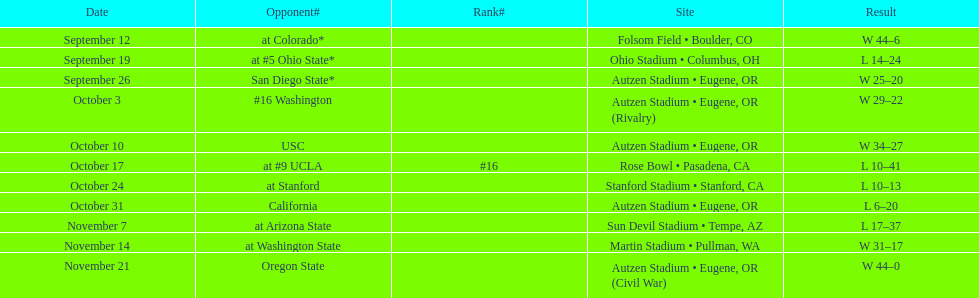Would you be able to parse every entry in this table? {'header': ['Date', 'Opponent#', 'Rank#', 'Site', 'Result'], 'rows': [['September 12', 'at\xa0Colorado*', '', 'Folsom Field • Boulder, CO', 'W\xa044–6'], ['September 19', 'at\xa0#5\xa0Ohio State*', '', 'Ohio Stadium • Columbus, OH', 'L\xa014–24'], ['September 26', 'San Diego State*', '', 'Autzen Stadium • Eugene, OR', 'W\xa025–20'], ['October 3', '#16\xa0Washington', '', 'Autzen Stadium • Eugene, OR (Rivalry)', 'W\xa029–22'], ['October 10', 'USC', '', 'Autzen Stadium • Eugene, OR', 'W\xa034–27'], ['October 17', 'at\xa0#9\xa0UCLA', '#16', 'Rose Bowl • Pasadena, CA', 'L\xa010–41'], ['October 24', 'at\xa0Stanford', '', 'Stanford Stadium • Stanford, CA', 'L\xa010–13'], ['October 31', 'California', '', 'Autzen Stadium • Eugene, OR', 'L\xa06–20'], ['November 7', 'at\xa0Arizona State', '', 'Sun Devil Stadium • Tempe, AZ', 'L\xa017–37'], ['November 14', 'at\xa0Washington State', '', 'Martin Stadium • Pullman, WA', 'W\xa031–17'], ['November 21', 'Oregon State', '', 'Autzen Stadium • Eugene, OR (Civil War)', 'W\xa044–0']]} Which bowl game did the university of oregon ducks football team play in during the 1987 season? Rose Bowl. 